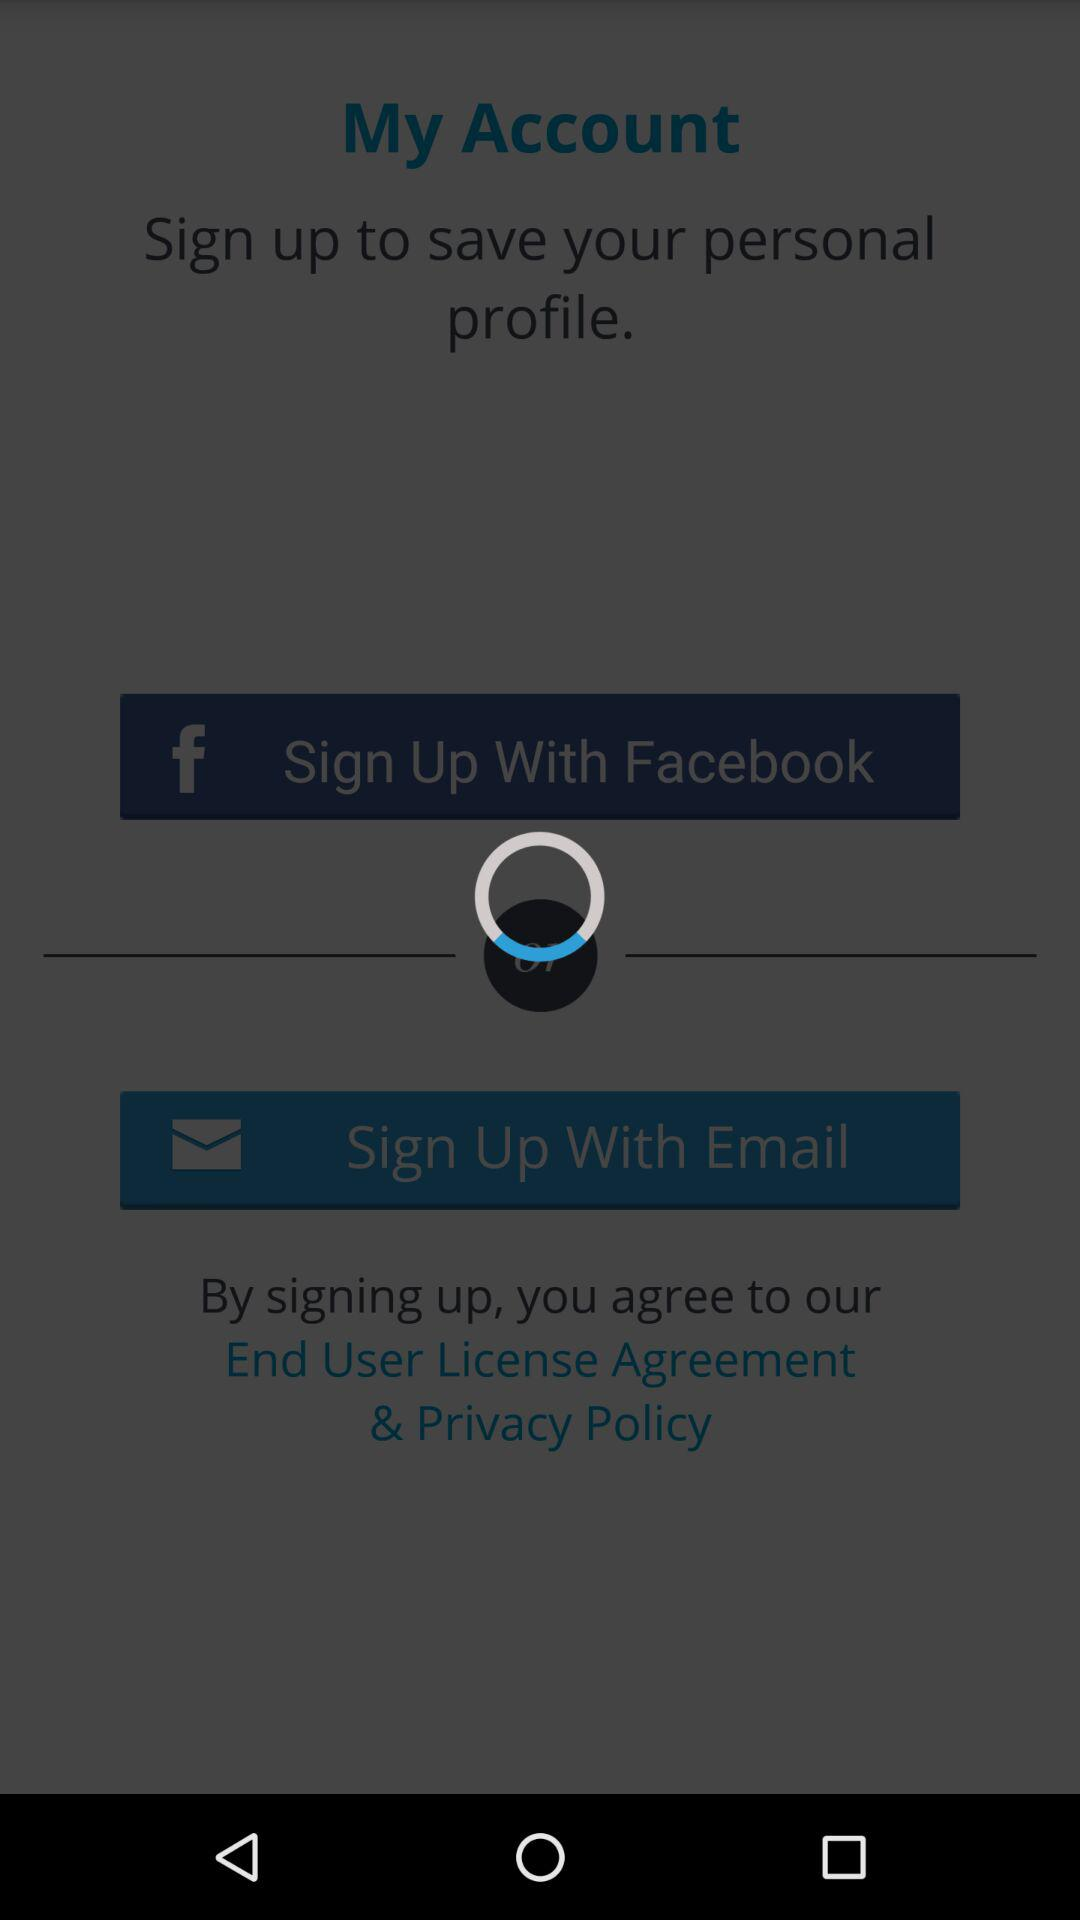Through what application can we sign up to the account? You can sign up through "Facebook". 